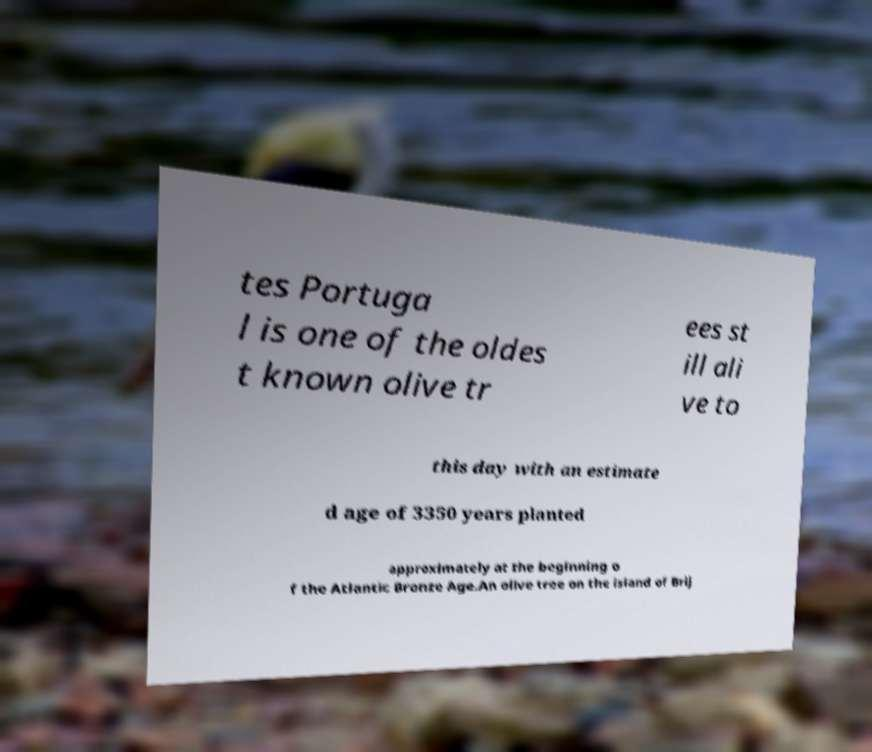Can you read and provide the text displayed in the image?This photo seems to have some interesting text. Can you extract and type it out for me? tes Portuga l is one of the oldes t known olive tr ees st ill ali ve to this day with an estimate d age of 3350 years planted approximately at the beginning o f the Atlantic Bronze Age.An olive tree on the island of Brij 